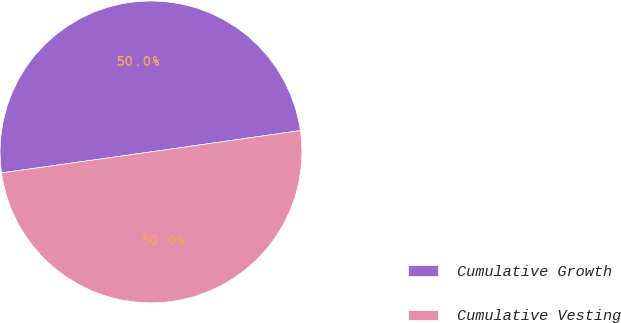Convert chart. <chart><loc_0><loc_0><loc_500><loc_500><pie_chart><fcel>Cumulative Growth<fcel>Cumulative Vesting<nl><fcel>49.97%<fcel>50.03%<nl></chart> 